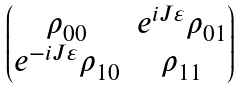Convert formula to latex. <formula><loc_0><loc_0><loc_500><loc_500>\begin{pmatrix} \rho _ { 0 0 } & e ^ { i J \varepsilon } \rho _ { 0 1 } \\ e ^ { - i J \varepsilon } \rho _ { 1 0 } & \rho _ { 1 1 } \end{pmatrix}</formula> 